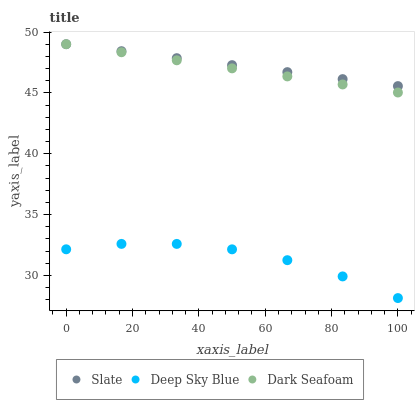Does Deep Sky Blue have the minimum area under the curve?
Answer yes or no. Yes. Does Slate have the maximum area under the curve?
Answer yes or no. Yes. Does Dark Seafoam have the minimum area under the curve?
Answer yes or no. No. Does Dark Seafoam have the maximum area under the curve?
Answer yes or no. No. Is Dark Seafoam the smoothest?
Answer yes or no. Yes. Is Deep Sky Blue the roughest?
Answer yes or no. Yes. Is Deep Sky Blue the smoothest?
Answer yes or no. No. Is Dark Seafoam the roughest?
Answer yes or no. No. Does Deep Sky Blue have the lowest value?
Answer yes or no. Yes. Does Dark Seafoam have the lowest value?
Answer yes or no. No. Does Dark Seafoam have the highest value?
Answer yes or no. Yes. Does Deep Sky Blue have the highest value?
Answer yes or no. No. Is Deep Sky Blue less than Slate?
Answer yes or no. Yes. Is Slate greater than Deep Sky Blue?
Answer yes or no. Yes. Does Dark Seafoam intersect Slate?
Answer yes or no. Yes. Is Dark Seafoam less than Slate?
Answer yes or no. No. Is Dark Seafoam greater than Slate?
Answer yes or no. No. Does Deep Sky Blue intersect Slate?
Answer yes or no. No. 